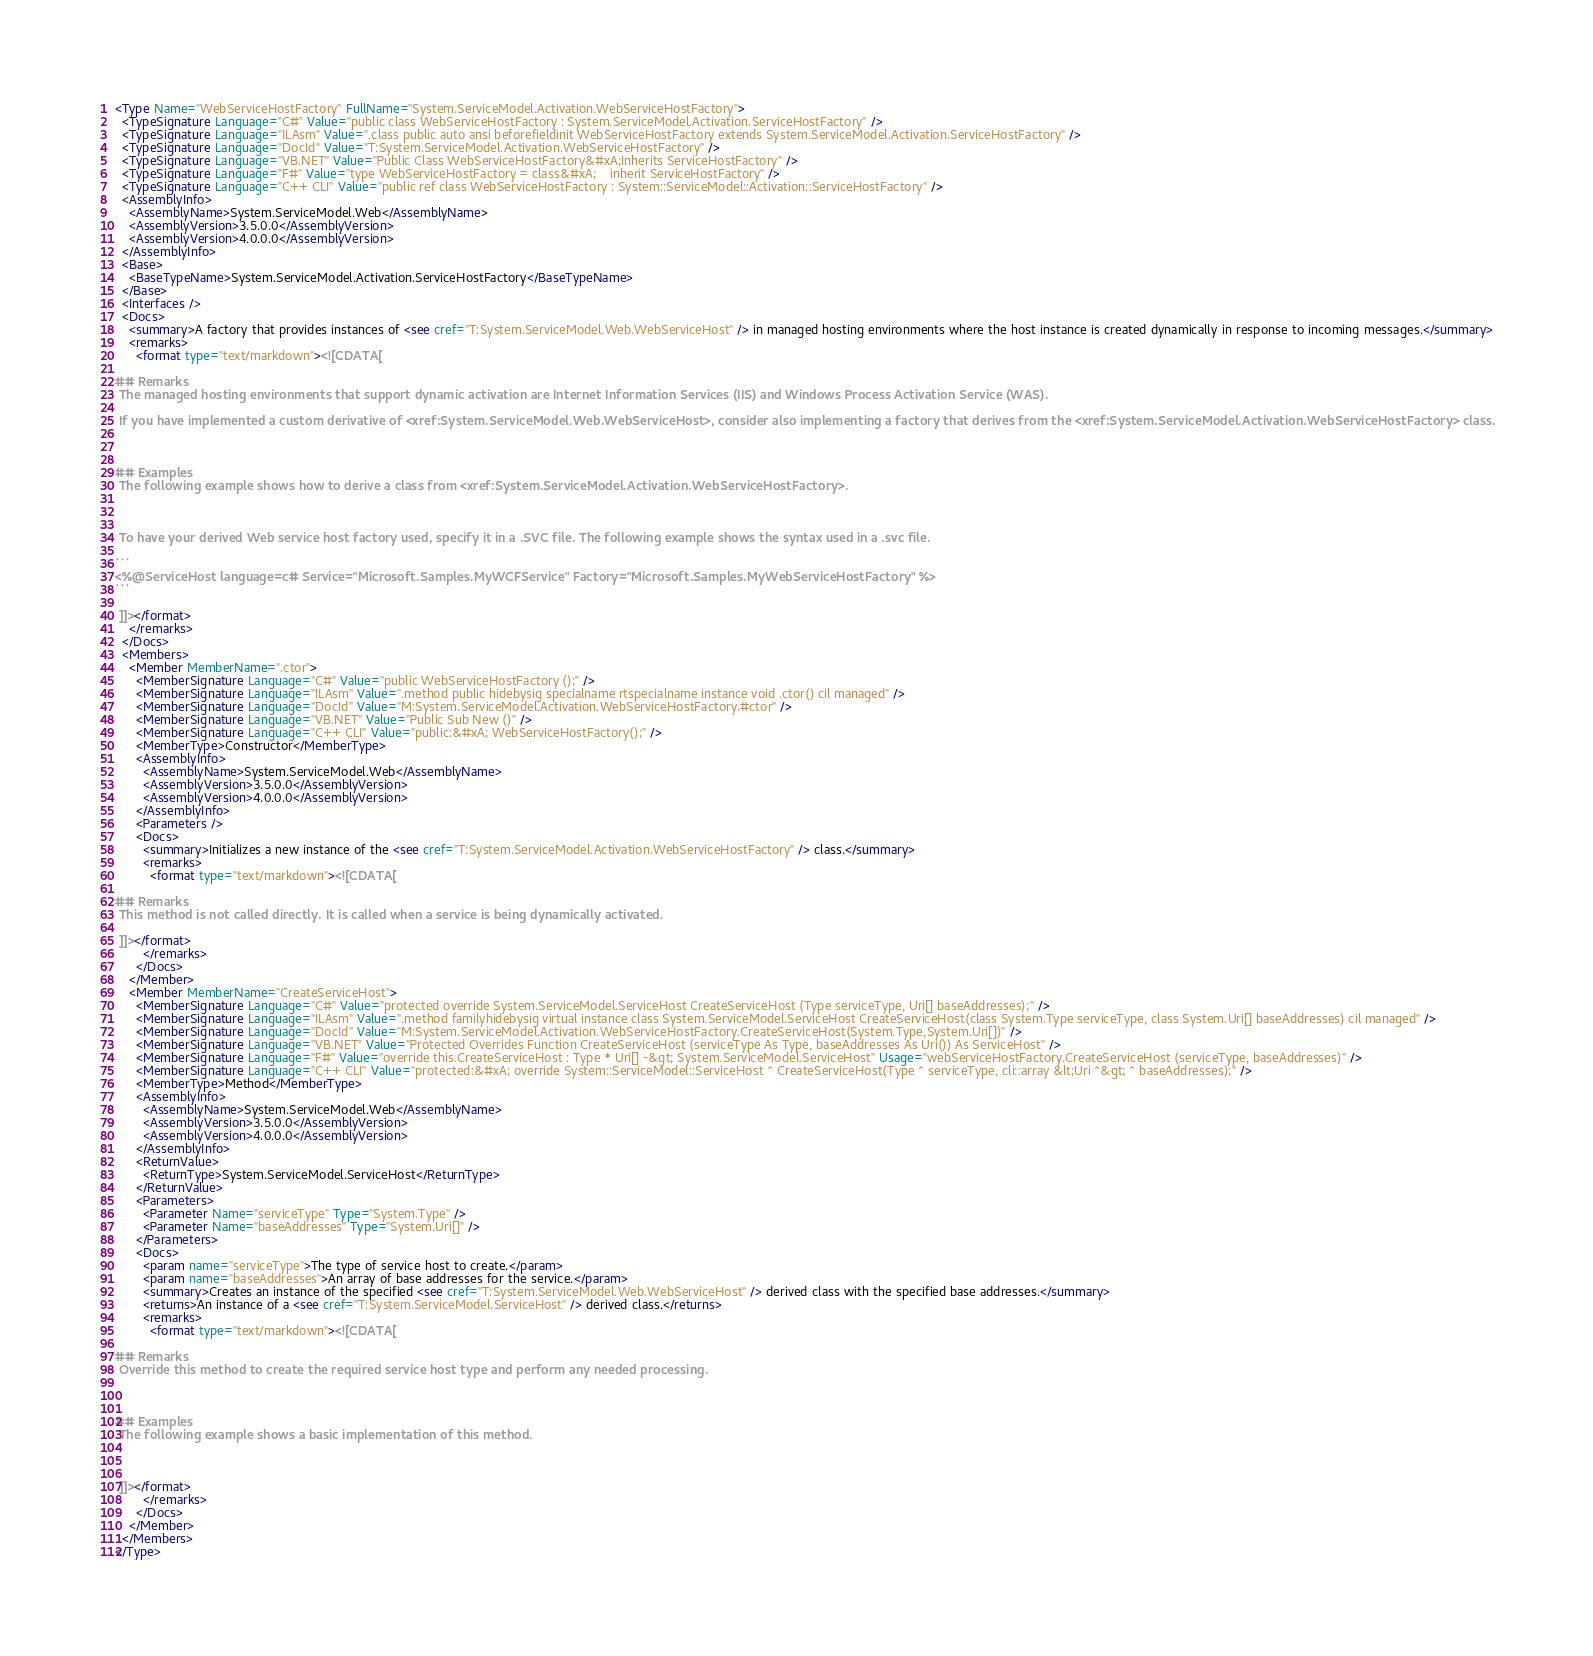<code> <loc_0><loc_0><loc_500><loc_500><_XML_><Type Name="WebServiceHostFactory" FullName="System.ServiceModel.Activation.WebServiceHostFactory">
  <TypeSignature Language="C#" Value="public class WebServiceHostFactory : System.ServiceModel.Activation.ServiceHostFactory" />
  <TypeSignature Language="ILAsm" Value=".class public auto ansi beforefieldinit WebServiceHostFactory extends System.ServiceModel.Activation.ServiceHostFactory" />
  <TypeSignature Language="DocId" Value="T:System.ServiceModel.Activation.WebServiceHostFactory" />
  <TypeSignature Language="VB.NET" Value="Public Class WebServiceHostFactory&#xA;Inherits ServiceHostFactory" />
  <TypeSignature Language="F#" Value="type WebServiceHostFactory = class&#xA;    inherit ServiceHostFactory" />
  <TypeSignature Language="C++ CLI" Value="public ref class WebServiceHostFactory : System::ServiceModel::Activation::ServiceHostFactory" />
  <AssemblyInfo>
    <AssemblyName>System.ServiceModel.Web</AssemblyName>
    <AssemblyVersion>3.5.0.0</AssemblyVersion>
    <AssemblyVersion>4.0.0.0</AssemblyVersion>
  </AssemblyInfo>
  <Base>
    <BaseTypeName>System.ServiceModel.Activation.ServiceHostFactory</BaseTypeName>
  </Base>
  <Interfaces />
  <Docs>
    <summary>A factory that provides instances of <see cref="T:System.ServiceModel.Web.WebServiceHost" /> in managed hosting environments where the host instance is created dynamically in response to incoming messages.</summary>
    <remarks>
      <format type="text/markdown"><![CDATA[  
  
## Remarks  
 The managed hosting environments that support dynamic activation are Internet Information Services (IIS) and Windows Process Activation Service (WAS).  
  
 If you have implemented a custom derivative of <xref:System.ServiceModel.Web.WebServiceHost>, consider also implementing a factory that derives from the <xref:System.ServiceModel.Activation.WebServiceHostFactory> class.  
  
   
  
## Examples  
 The following example shows how to derive a class from <xref:System.ServiceModel.Activation.WebServiceHostFactory>.  
  
  
  
 To have your derived Web service host factory used, specify it in a .SVC file. The following example shows the syntax used in a .svc file.  
  
```  
<%@ServiceHost language=c# Service="Microsoft.Samples.MyWCFService" Factory="Microsoft.Samples.MyWebServiceHostFactory" %>  
```  
  
 ]]></format>
    </remarks>
  </Docs>
  <Members>
    <Member MemberName=".ctor">
      <MemberSignature Language="C#" Value="public WebServiceHostFactory ();" />
      <MemberSignature Language="ILAsm" Value=".method public hidebysig specialname rtspecialname instance void .ctor() cil managed" />
      <MemberSignature Language="DocId" Value="M:System.ServiceModel.Activation.WebServiceHostFactory.#ctor" />
      <MemberSignature Language="VB.NET" Value="Public Sub New ()" />
      <MemberSignature Language="C++ CLI" Value="public:&#xA; WebServiceHostFactory();" />
      <MemberType>Constructor</MemberType>
      <AssemblyInfo>
        <AssemblyName>System.ServiceModel.Web</AssemblyName>
        <AssemblyVersion>3.5.0.0</AssemblyVersion>
        <AssemblyVersion>4.0.0.0</AssemblyVersion>
      </AssemblyInfo>
      <Parameters />
      <Docs>
        <summary>Initializes a new instance of the <see cref="T:System.ServiceModel.Activation.WebServiceHostFactory" /> class.</summary>
        <remarks>
          <format type="text/markdown"><![CDATA[  
  
## Remarks  
 This method is not called directly. It is called when a service is being dynamically activated.  
  
 ]]></format>
        </remarks>
      </Docs>
    </Member>
    <Member MemberName="CreateServiceHost">
      <MemberSignature Language="C#" Value="protected override System.ServiceModel.ServiceHost CreateServiceHost (Type serviceType, Uri[] baseAddresses);" />
      <MemberSignature Language="ILAsm" Value=".method familyhidebysig virtual instance class System.ServiceModel.ServiceHost CreateServiceHost(class System.Type serviceType, class System.Uri[] baseAddresses) cil managed" />
      <MemberSignature Language="DocId" Value="M:System.ServiceModel.Activation.WebServiceHostFactory.CreateServiceHost(System.Type,System.Uri[])" />
      <MemberSignature Language="VB.NET" Value="Protected Overrides Function CreateServiceHost (serviceType As Type, baseAddresses As Uri()) As ServiceHost" />
      <MemberSignature Language="F#" Value="override this.CreateServiceHost : Type * Uri[] -&gt; System.ServiceModel.ServiceHost" Usage="webServiceHostFactory.CreateServiceHost (serviceType, baseAddresses)" />
      <MemberSignature Language="C++ CLI" Value="protected:&#xA; override System::ServiceModel::ServiceHost ^ CreateServiceHost(Type ^ serviceType, cli::array &lt;Uri ^&gt; ^ baseAddresses);" />
      <MemberType>Method</MemberType>
      <AssemblyInfo>
        <AssemblyName>System.ServiceModel.Web</AssemblyName>
        <AssemblyVersion>3.5.0.0</AssemblyVersion>
        <AssemblyVersion>4.0.0.0</AssemblyVersion>
      </AssemblyInfo>
      <ReturnValue>
        <ReturnType>System.ServiceModel.ServiceHost</ReturnType>
      </ReturnValue>
      <Parameters>
        <Parameter Name="serviceType" Type="System.Type" />
        <Parameter Name="baseAddresses" Type="System.Uri[]" />
      </Parameters>
      <Docs>
        <param name="serviceType">The type of service host to create.</param>
        <param name="baseAddresses">An array of base addresses for the service.</param>
        <summary>Creates an instance of the specified <see cref="T:System.ServiceModel.Web.WebServiceHost" /> derived class with the specified base addresses.</summary>
        <returns>An instance of a <see cref="T:System.ServiceModel.ServiceHost" /> derived class.</returns>
        <remarks>
          <format type="text/markdown"><![CDATA[  
  
## Remarks  
 Override this method to create the required service host type and perform any needed processing.  
  
   
  
## Examples  
 The following example shows a basic implementation of this method.  
  
  
  
 ]]></format>
        </remarks>
      </Docs>
    </Member>
  </Members>
</Type>
</code> 